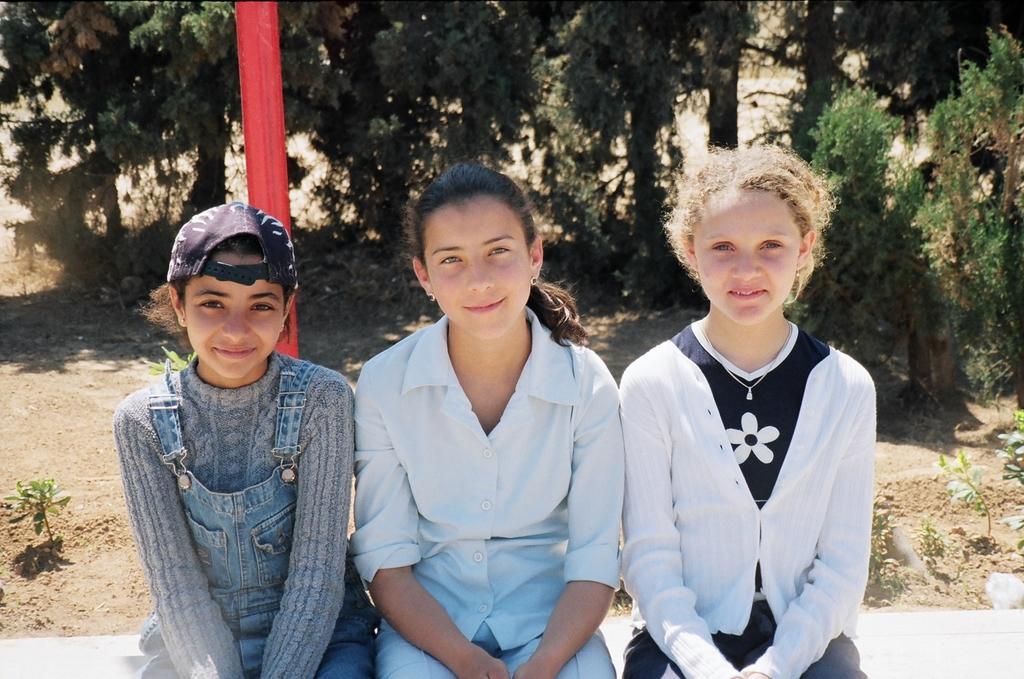Please provide a concise description of this image. The 3 girls are sitting on a wall. This 3 girls smile beautifully. This 2 girls wore white shirt. This girl wore cap and a dungaree. Far there are number of trees in green color. Backside of this girl there is red color pole. 